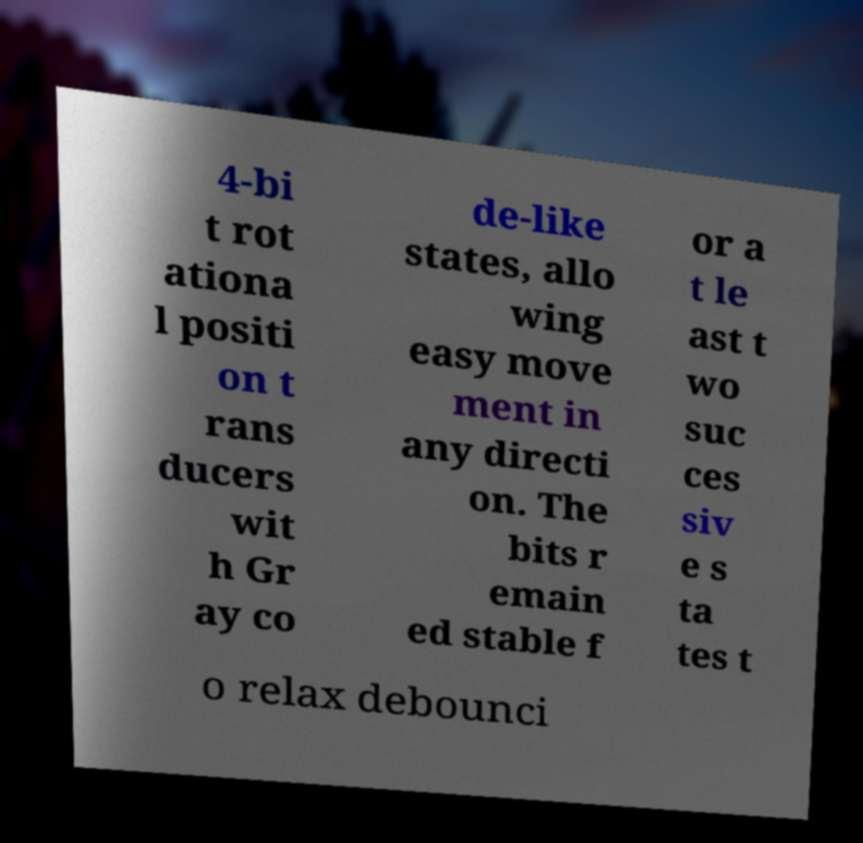What messages or text are displayed in this image? I need them in a readable, typed format. 4-bi t rot ationa l positi on t rans ducers wit h Gr ay co de-like states, allo wing easy move ment in any directi on. The bits r emain ed stable f or a t le ast t wo suc ces siv e s ta tes t o relax debounci 